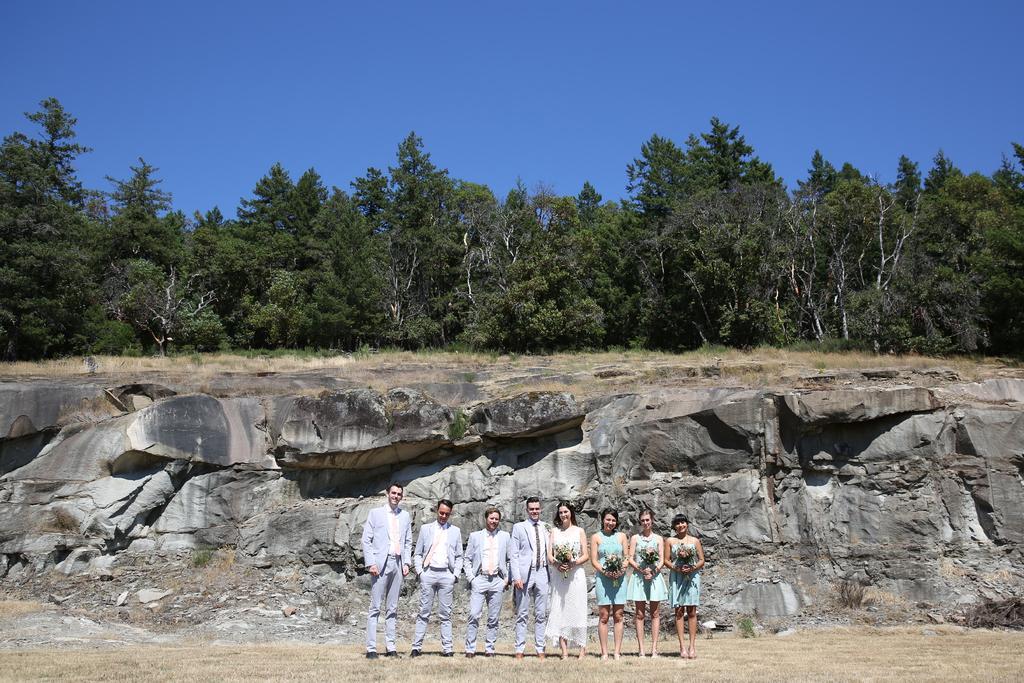Describe this image in one or two sentences. In the middle of the image we can see group of people, few people holding bouquets, behind them we can find few rocks and trees. 